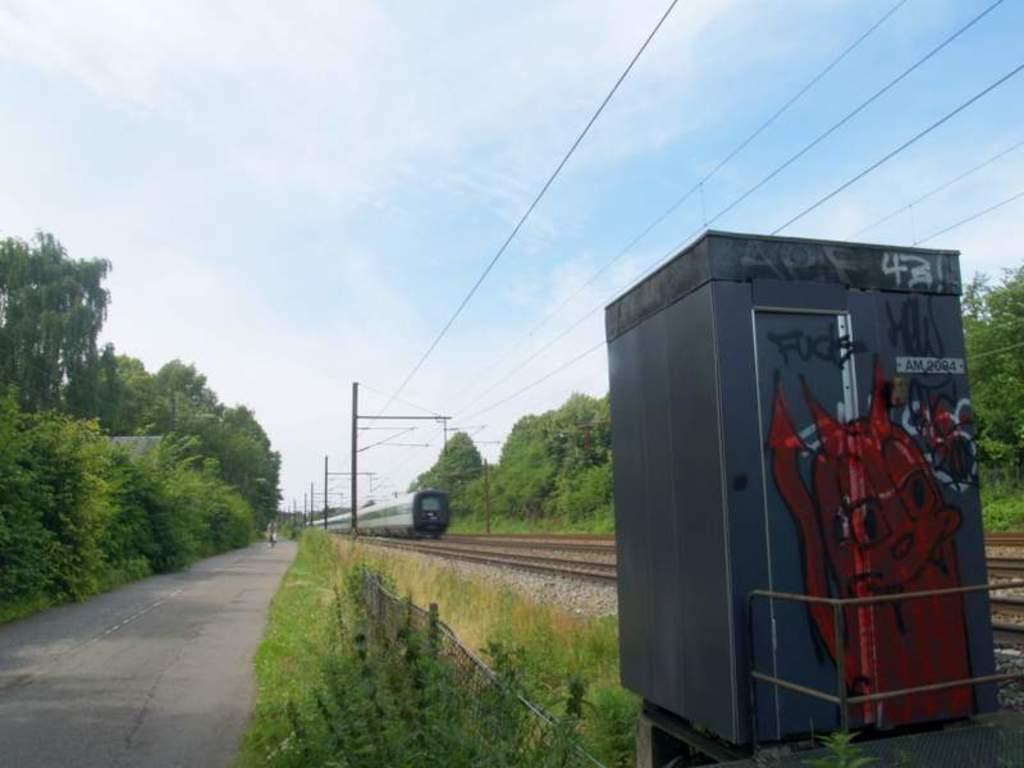Please provide a concise description of this image. In this image we can see a train on the track, there are some trees, poles, wires, grass and a booth, also we can see the sky with clouds. 